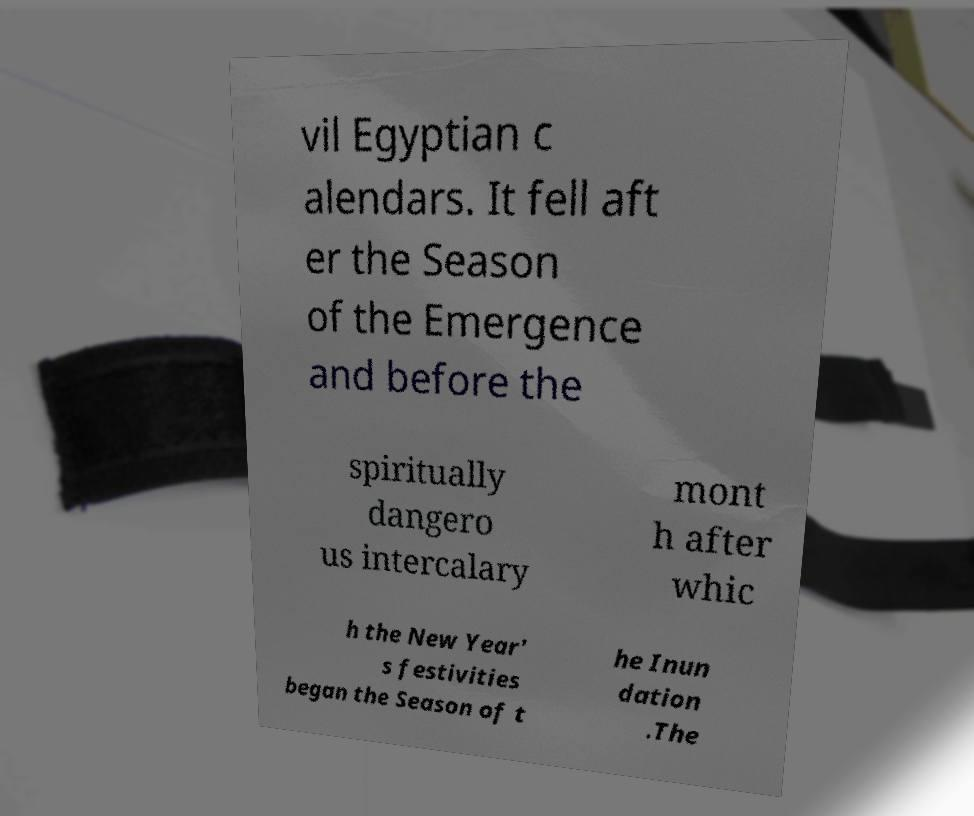Can you read and provide the text displayed in the image?This photo seems to have some interesting text. Can you extract and type it out for me? vil Egyptian c alendars. It fell aft er the Season of the Emergence and before the spiritually dangero us intercalary mont h after whic h the New Year' s festivities began the Season of t he Inun dation .The 